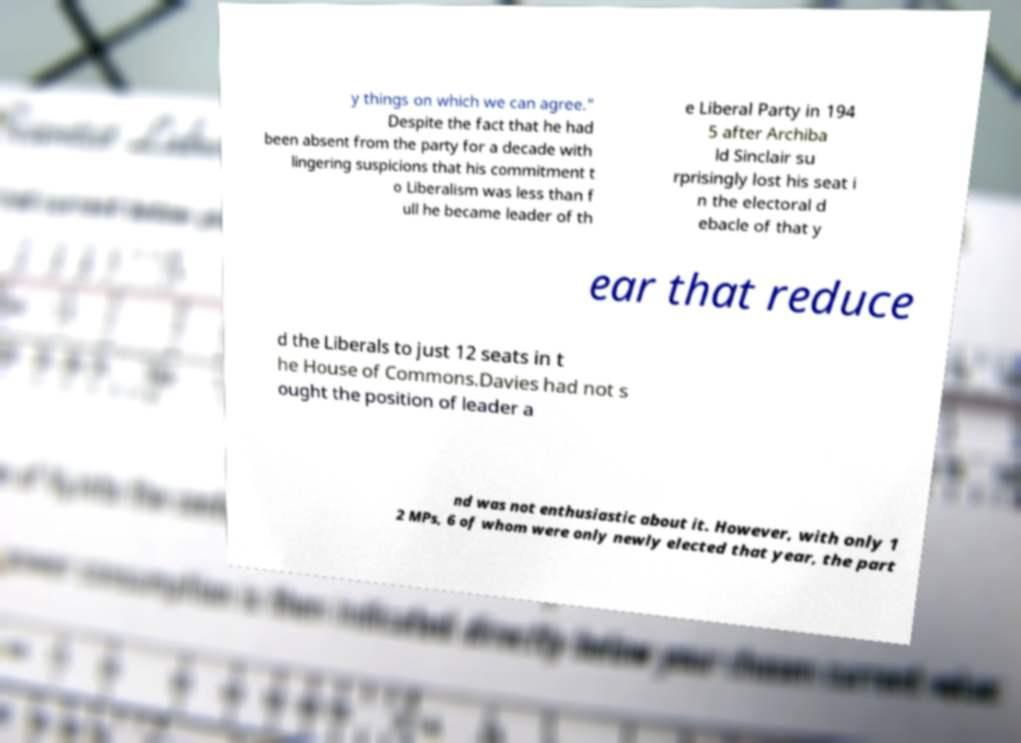For documentation purposes, I need the text within this image transcribed. Could you provide that? y things on which we can agree." Despite the fact that he had been absent from the party for a decade with lingering suspicions that his commitment t o Liberalism was less than f ull he became leader of th e Liberal Party in 194 5 after Archiba ld Sinclair su rprisingly lost his seat i n the electoral d ebacle of that y ear that reduce d the Liberals to just 12 seats in t he House of Commons.Davies had not s ought the position of leader a nd was not enthusiastic about it. However, with only 1 2 MPs, 6 of whom were only newly elected that year, the part 